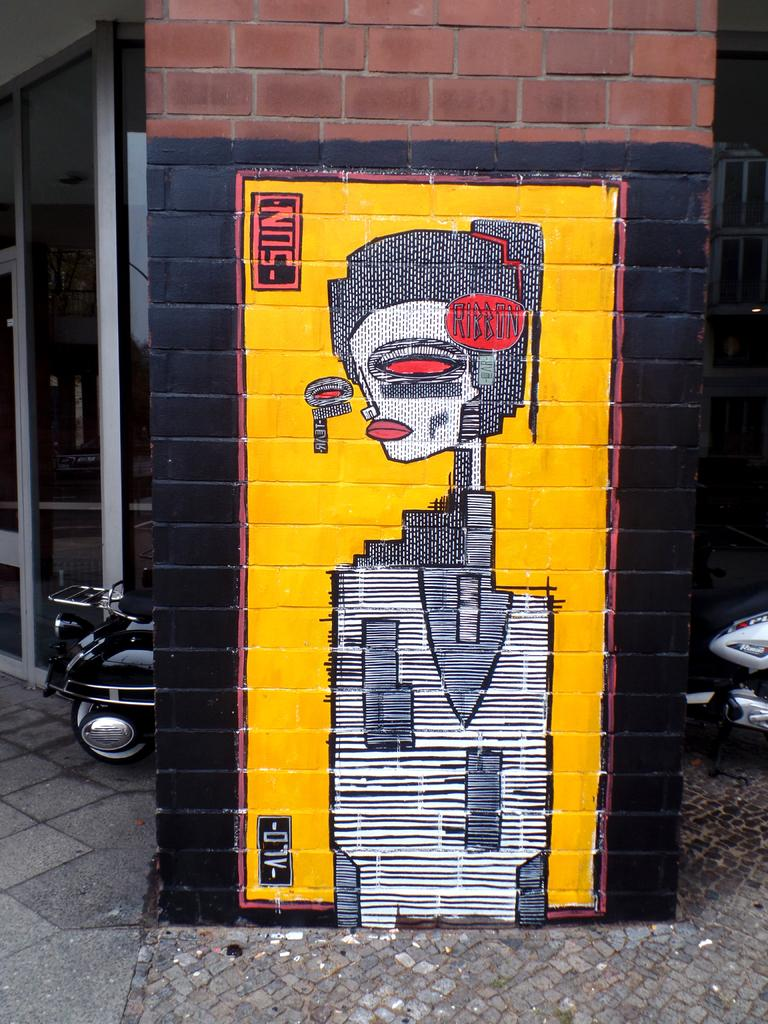What type of structure is present in the image? There is a brick wall in the image. What is depicted on the brick wall? A painting is made on the brick wall. What can be seen behind the wall in the image? There are vehicles visible behind the wall. What type of building is present in the image? There is a building with a glass door in the image. What design process was used to create the painting on the wall? The provided facts do not mention any specific design process used to create the painting on the wall. 